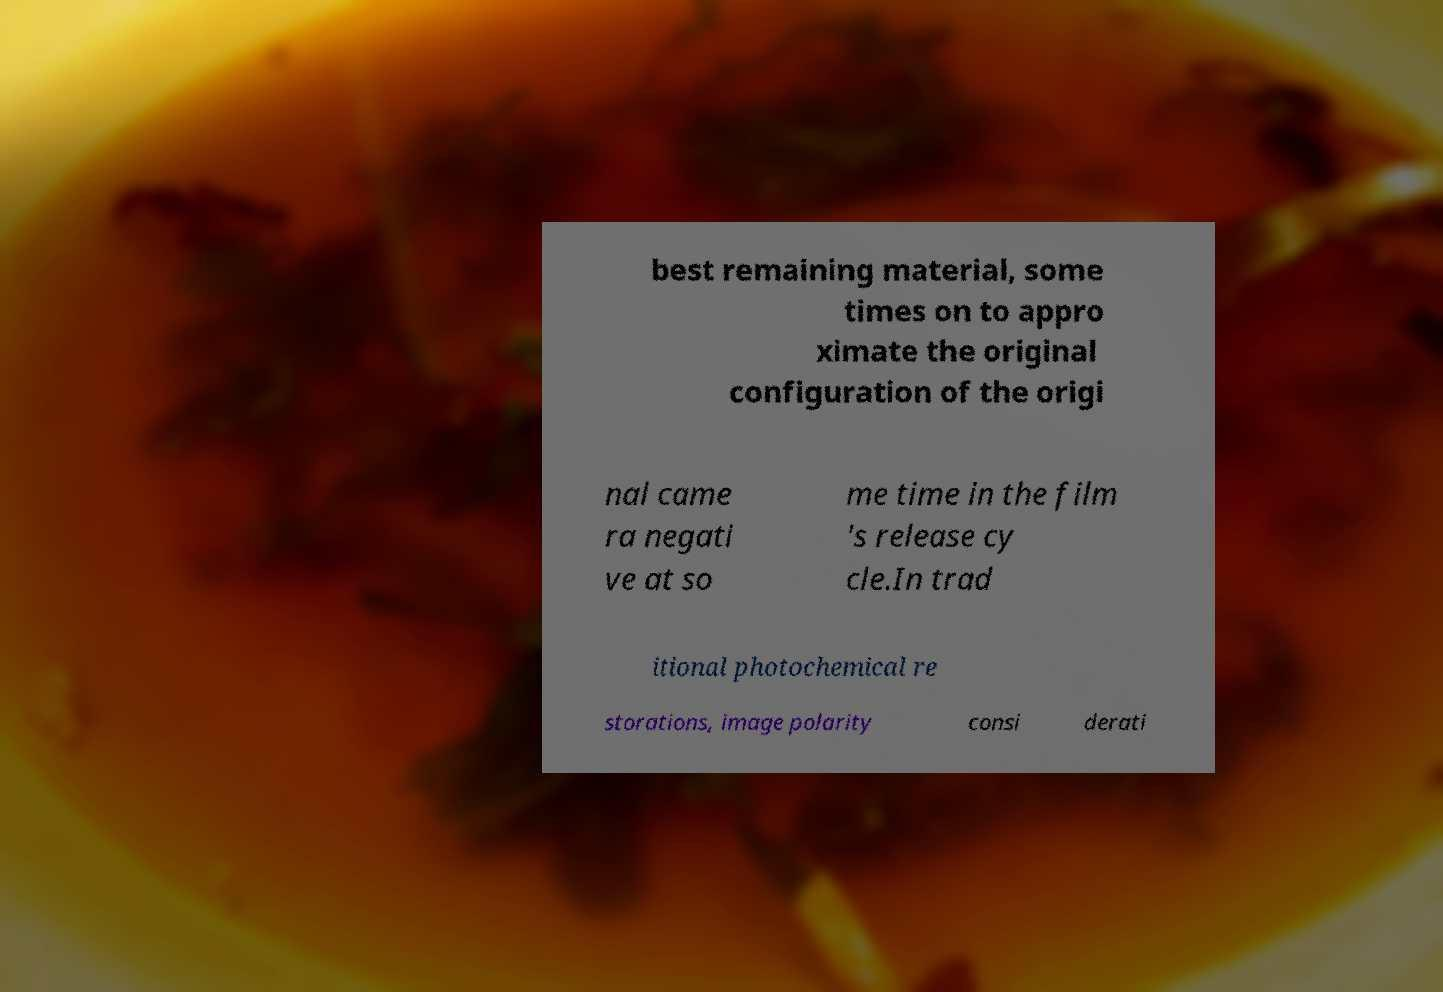There's text embedded in this image that I need extracted. Can you transcribe it verbatim? best remaining material, some times on to appro ximate the original configuration of the origi nal came ra negati ve at so me time in the film 's release cy cle.In trad itional photochemical re storations, image polarity consi derati 